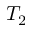Convert formula to latex. <formula><loc_0><loc_0><loc_500><loc_500>T _ { 2 }</formula> 